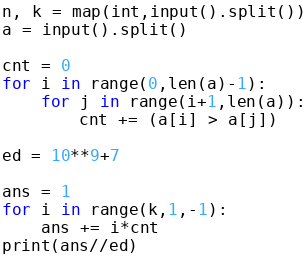<code> <loc_0><loc_0><loc_500><loc_500><_Python_>n, k = map(int,input().split())
a = input().split()

cnt = 0
for i in range(0,len(a)-1):
    for j in range(i+1,len(a)):
        cnt += (a[i] > a[j])

ed = 10**9+7

ans = 1
for i in range(k,1,-1):
    ans += i*cnt 
print(ans//ed)</code> 